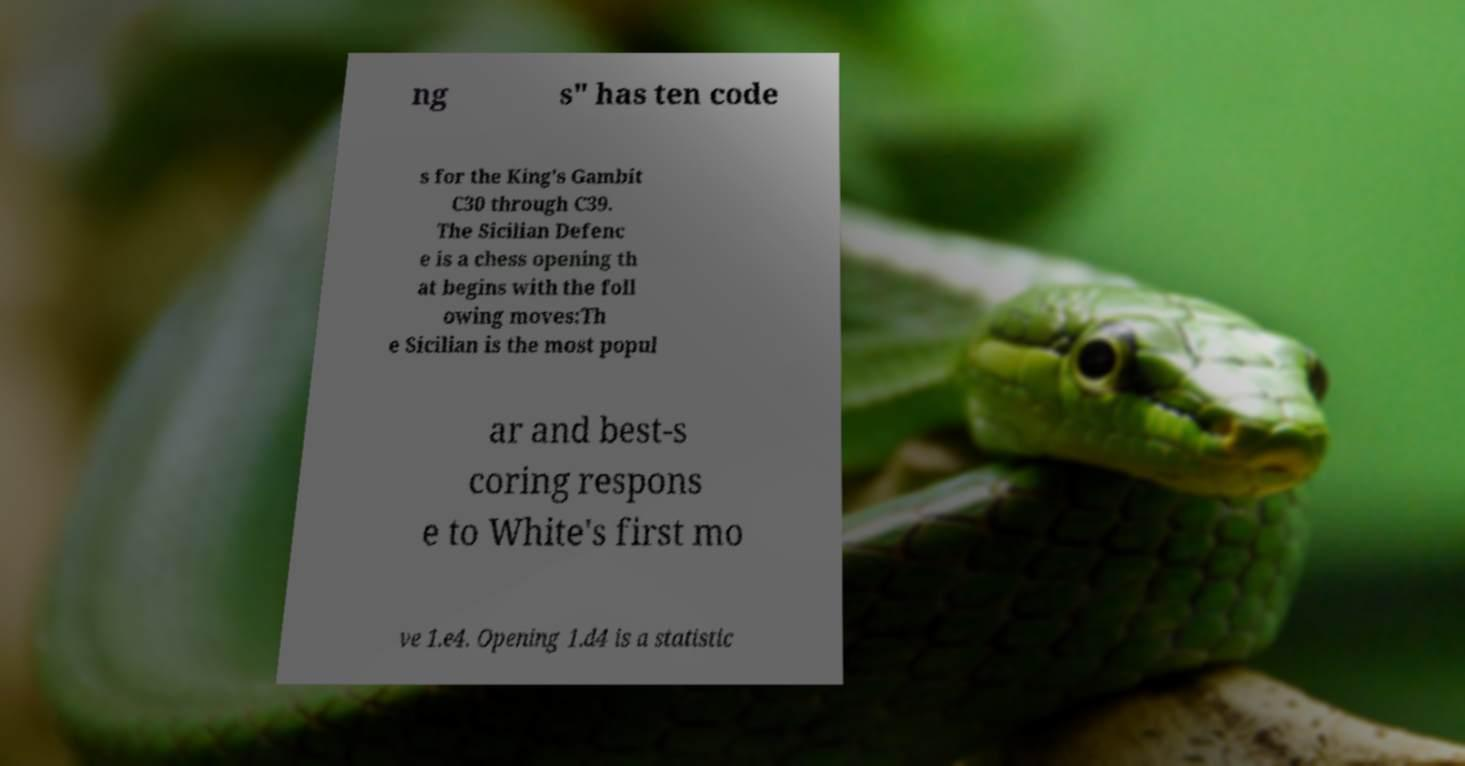I need the written content from this picture converted into text. Can you do that? ng s" has ten code s for the King's Gambit C30 through C39. The Sicilian Defenc e is a chess opening th at begins with the foll owing moves:Th e Sicilian is the most popul ar and best-s coring respons e to White's first mo ve 1.e4. Opening 1.d4 is a statistic 